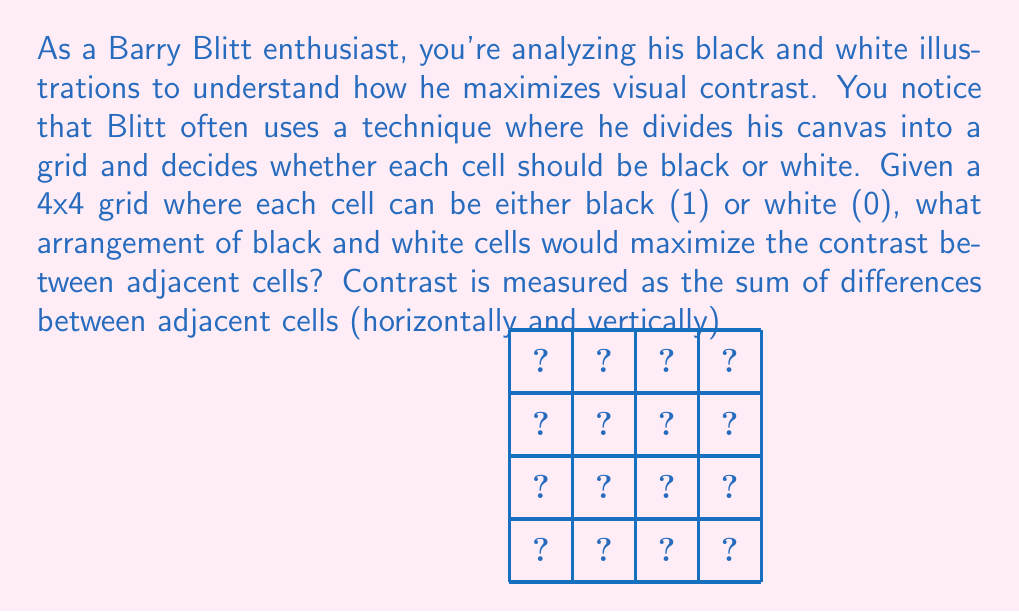Provide a solution to this math problem. To maximize the contrast in this 4x4 grid, we need to create a checkerboard pattern. Here's why:

1. Each cell has up to 4 adjacent cells (top, bottom, left, right).
2. The contrast between adjacent cells is 1 if they're different colors, and 0 if they're the same.
3. A checkerboard pattern ensures that every cell is surrounded by cells of the opposite color.

Let's calculate the total contrast:

1. For interior cells (4 of them):
   Each has 4 adjacent cells, all different. Contrast = 4 × 4 = 16

2. For edge cells (8 of them):
   Each has 3 adjacent cells, all different. Contrast = 8 × 3 = 24

3. For corner cells (4 of them):
   Each has 2 adjacent cells, both different. Contrast = 4 × 2 = 8

Total contrast = 16 + 24 + 8 = 48

This is the maximum possible contrast for a 4x4 grid.

The optimal arrangement would look like this:

[asy]
unitsize(1cm);
for(int i=0; i<5; ++i) {
  draw((0,i)--(4,i));
  draw((i,0)--(i,4));
}
fill((0,3)--(1,3)--(1,4)--(0,4)--cycle, black);
fill((2,3)--(3,3)--(3,4)--(2,4)--cycle, black);
fill((1,2)--(2,2)--(2,3)--(1,3)--cycle, black);
fill((3,2)--(4,2)--(4,3)--(3,3)--cycle, black);
fill((0,1)--(1,1)--(1,2)--(0,2)--cycle, black);
fill((2,1)--(3,1)--(3,2)--(2,2)--cycle, black);
fill((1,0)--(2,0)--(2,1)--(1,1)--cycle, black);
fill((3,0)--(4,0)--(4,1)--(3,1)--cycle, black);
[/asy]

We can represent this pattern mathematically as:

$$
\begin{bmatrix}
1 & 0 & 1 & 0 \\
0 & 1 & 0 & 1 \\
1 & 0 & 1 & 0 \\
0 & 1 & 0 & 1
\end{bmatrix}
$$

Where 1 represents black and 0 represents white.
Answer: Checkerboard pattern with total contrast of 48 